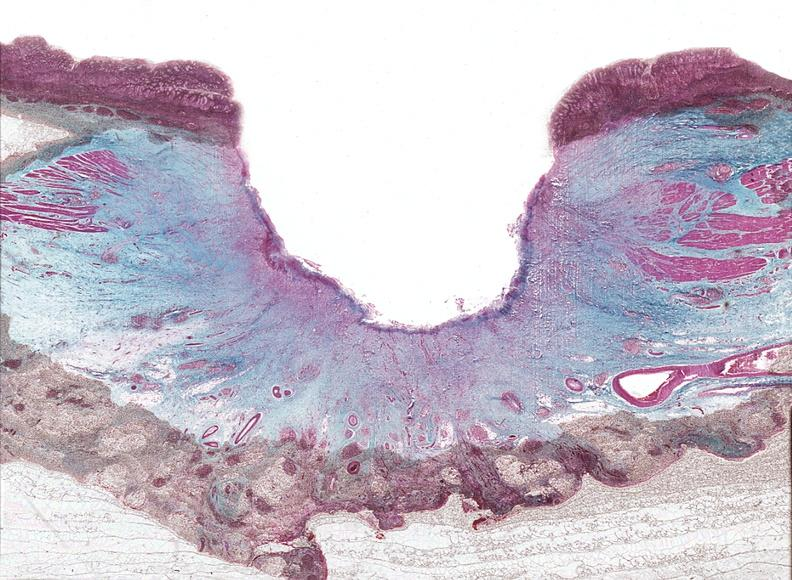does chromophobe adenoma show stomach, chronic peptic ulcer?
Answer the question using a single word or phrase. No 